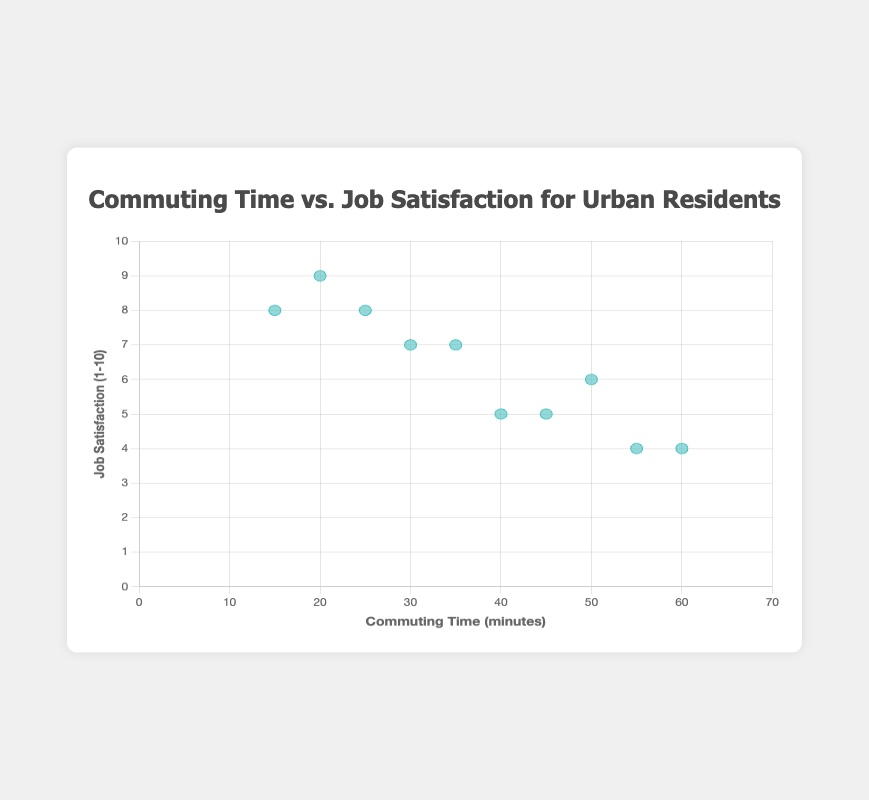What's the title of the chart? The title of the chart is typically displayed at the top of the chart.
Answer: Commuting Time vs. Job Satisfaction for Urban Residents How many data points are displayed on the scatter plot? Looking at the data provided, there are 10 entries, each corresponding to one data point.
Answer: 10 What does the x-axis represent, and what does the y-axis represent? The x-axis represents 'Commuting Time (minutes)', and the y-axis represents 'Job Satisfaction (1-10)'.
Answer: Commuting Time (minutes), Job Satisfaction (1-10) Which user has the highest commuting time? By reviewing the data points on the scatter plot, Kemal has the highest commuting time at 60 minutes.
Answer: Kemal What are the commuting time and job satisfaction for Ahmet? Ahmet's data point on the scatter plot shows a commuting time of 25 minutes and a job satisfaction score of 8.
Answer: 25 minutes, 8 How many users have a job satisfaction score below 6? Looking at the data points, 3 users (Mustafa, Kemal, and Murat) have job satisfaction scores below 6.
Answer: 3 Which user has the lowest job satisfaction, and what is their commuting time? Kemal and Murat both have the lowest job satisfaction score of 4. Kemal's commuting time is 60 minutes, and Murat's is 55 minutes.
Answer: Kemal, Murat What is the average commuting time of users with a job satisfaction score of 7? Users with job satisfaction scores of 7 are Elif and Emine, with commuting times of 30 and 35 minutes respectively. The average commuting time is (30+35)/2 = 32.5 minutes.
Answer: 32.5 minutes Is there a visible trend or relationship between commuting time and job satisfaction? By looking at the scatter plot, there seems to be a general trend that suggests higher commuting times might coincide with lower job satisfaction, though it's not perfectly linear.
Answer: Higher commuting times, lower job satisfaction 